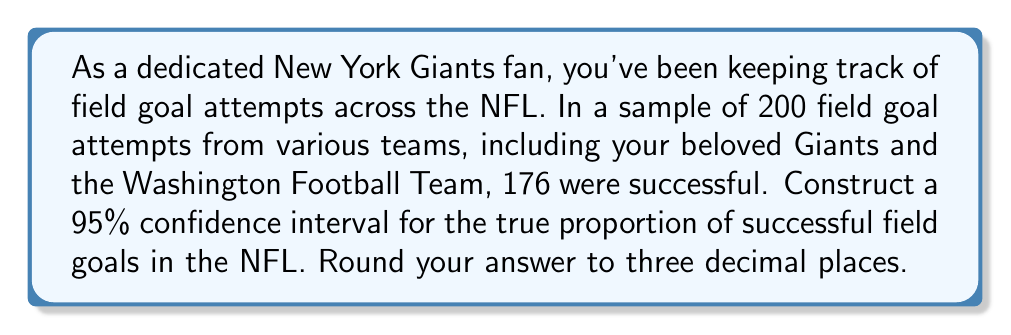Provide a solution to this math problem. Let's approach this step-by-step:

1) We're dealing with a population proportion, so we'll use the formula for a confidence interval of a proportion:

   $$\hat{p} \pm z^* \sqrt{\frac{\hat{p}(1-\hat{p})}{n}}$$

   Where:
   $\hat{p}$ is the sample proportion
   $z^*$ is the critical value
   $n$ is the sample size

2) Calculate $\hat{p}$:
   $$\hat{p} = \frac{176}{200} = 0.88$$

3) For a 95% confidence interval, $z^* = 1.96$

4) Now, let's plug these values into our formula:

   $$0.88 \pm 1.96 \sqrt{\frac{0.88(1-0.88)}{200}}$$

5) Simplify under the square root:
   
   $$0.88 \pm 1.96 \sqrt{\frac{0.88(0.12)}{200}} = 0.88 \pm 1.96 \sqrt{0.000528}$$

6) Calculate:
   
   $$0.88 \pm 1.96(0.0229885) = 0.88 \pm 0.0450574$$

7) Therefore, the confidence interval is:

   $$(0.88 - 0.0450574, 0.88 + 0.0450574) = (0.8349426, 0.9250574)$$

8) Rounding to three decimal places:

   $$(0.835, 0.925)$$
Answer: (0.835, 0.925) 